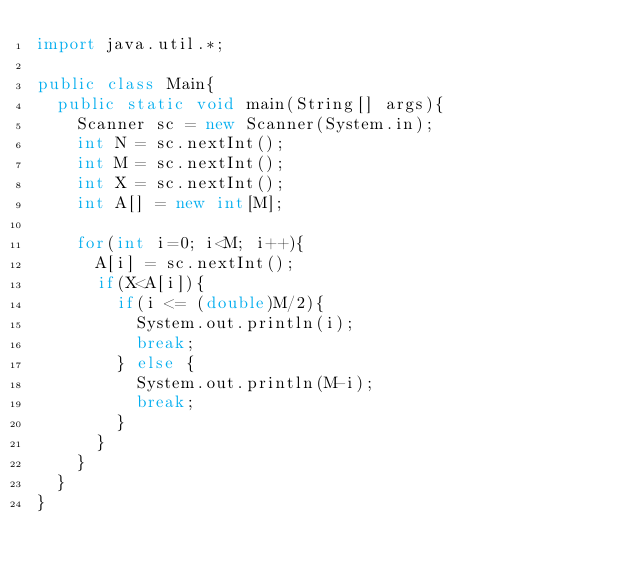<code> <loc_0><loc_0><loc_500><loc_500><_Java_>import java.util.*;

public class Main{
  public static void main(String[] args){
    Scanner sc = new Scanner(System.in);
    int N = sc.nextInt();
    int M = sc.nextInt();
    int X = sc.nextInt();
    int A[] = new int[M];
    
    for(int i=0; i<M; i++){
      A[i] = sc.nextInt();
      if(X<A[i]){
        if(i <= (double)M/2){
          System.out.println(i);
          break;
        } else {
          System.out.println(M-i);
          break;
        }
      }
    }
  }
}</code> 